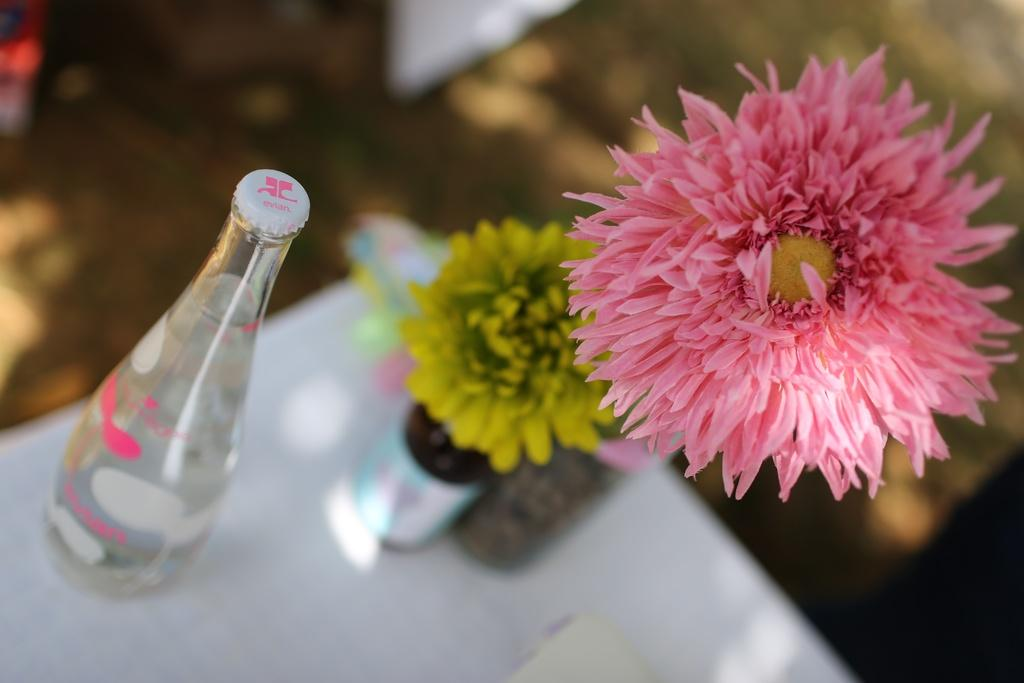What object is present in the image that people might use for hydration? There is a water bottle in the image. What type of living organisms can be seen in the image? There are two flowers in the image. What are the colors of the flowers? One flower is pink in color, and the other flower is yellow in color. Where are all the elements in the image located? All elements are on a table. How many trees can be seen in the image? There are no trees present in the image. What type of measurement is being taken in the image? There is no measurement being taken in the image. 